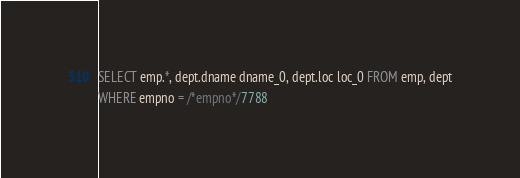Convert code to text. <code><loc_0><loc_0><loc_500><loc_500><_SQL_>SELECT emp.*, dept.dname dname_0, dept.loc loc_0 FROM emp, dept
WHERE empno = /*empno*/7788</code> 